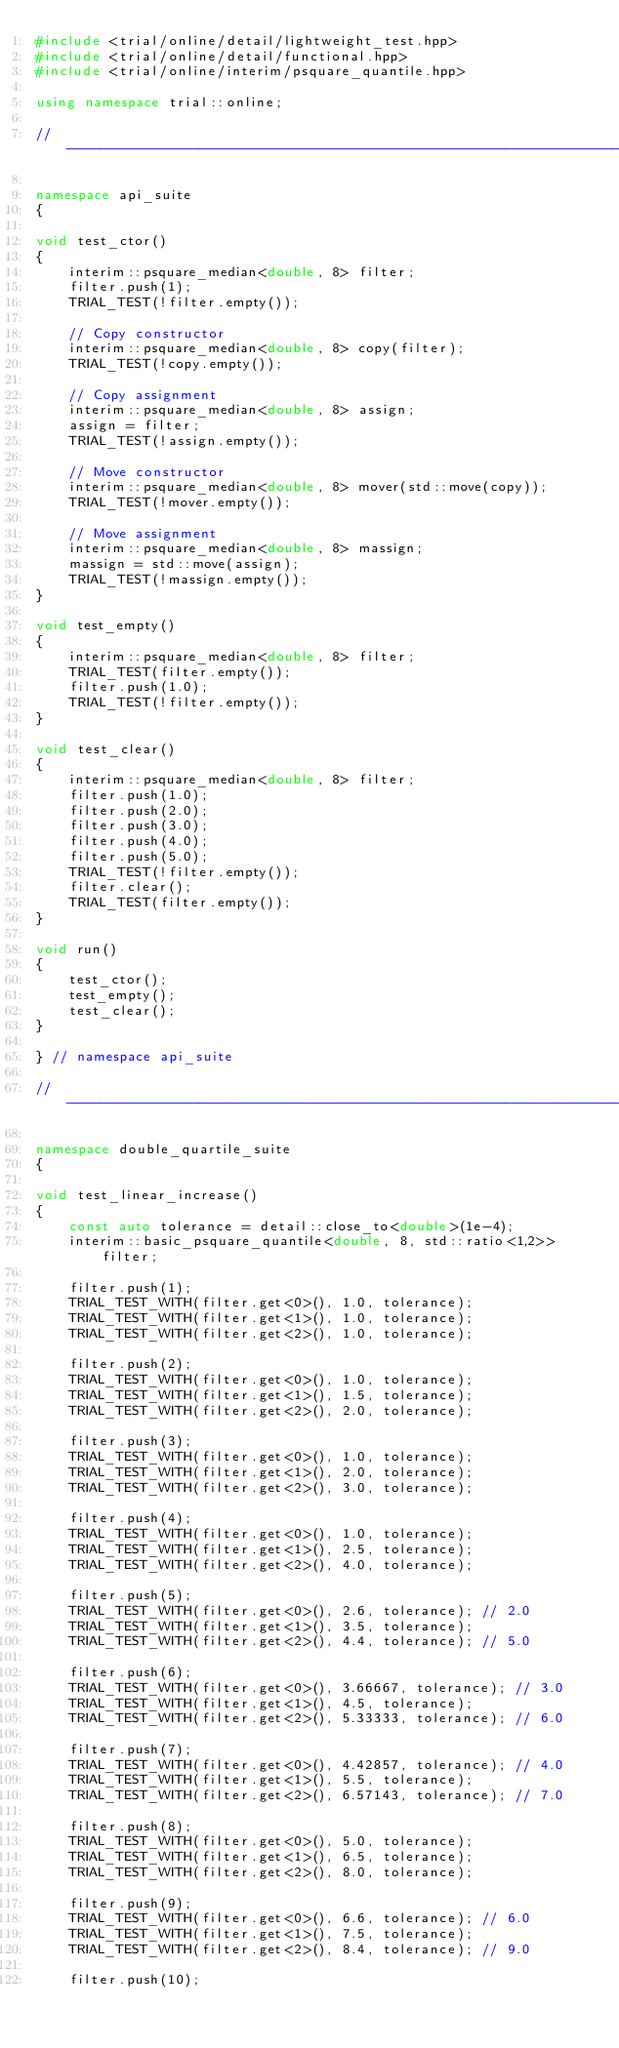Convert code to text. <code><loc_0><loc_0><loc_500><loc_500><_C++_>#include <trial/online/detail/lightweight_test.hpp>
#include <trial/online/detail/functional.hpp>
#include <trial/online/interim/psquare_quantile.hpp>

using namespace trial::online;

//-----------------------------------------------------------------------------

namespace api_suite
{

void test_ctor()
{
    interim::psquare_median<double, 8> filter;
    filter.push(1);
    TRIAL_TEST(!filter.empty());

    // Copy constructor
    interim::psquare_median<double, 8> copy(filter);
    TRIAL_TEST(!copy.empty());

    // Copy assignment
    interim::psquare_median<double, 8> assign;
    assign = filter;
    TRIAL_TEST(!assign.empty());

    // Move constructor
    interim::psquare_median<double, 8> mover(std::move(copy));
    TRIAL_TEST(!mover.empty());

    // Move assignment
    interim::psquare_median<double, 8> massign;
    massign = std::move(assign);
    TRIAL_TEST(!massign.empty());
}

void test_empty()
{
    interim::psquare_median<double, 8> filter;
    TRIAL_TEST(filter.empty());
    filter.push(1.0);
    TRIAL_TEST(!filter.empty());
}

void test_clear()
{
    interim::psquare_median<double, 8> filter;
    filter.push(1.0);
    filter.push(2.0);
    filter.push(3.0);
    filter.push(4.0);
    filter.push(5.0);
    TRIAL_TEST(!filter.empty());
    filter.clear();
    TRIAL_TEST(filter.empty());
}

void run()
{
    test_ctor();
    test_empty();
    test_clear();
}

} // namespace api_suite

//-----------------------------------------------------------------------------

namespace double_quartile_suite
{

void test_linear_increase()
{
    const auto tolerance = detail::close_to<double>(1e-4);
    interim::basic_psquare_quantile<double, 8, std::ratio<1,2>> filter;

    filter.push(1);
    TRIAL_TEST_WITH(filter.get<0>(), 1.0, tolerance);
    TRIAL_TEST_WITH(filter.get<1>(), 1.0, tolerance);
    TRIAL_TEST_WITH(filter.get<2>(), 1.0, tolerance);

    filter.push(2);
    TRIAL_TEST_WITH(filter.get<0>(), 1.0, tolerance);
    TRIAL_TEST_WITH(filter.get<1>(), 1.5, tolerance);
    TRIAL_TEST_WITH(filter.get<2>(), 2.0, tolerance);

    filter.push(3);
    TRIAL_TEST_WITH(filter.get<0>(), 1.0, tolerance);
    TRIAL_TEST_WITH(filter.get<1>(), 2.0, tolerance);
    TRIAL_TEST_WITH(filter.get<2>(), 3.0, tolerance);

    filter.push(4);
    TRIAL_TEST_WITH(filter.get<0>(), 1.0, tolerance);
    TRIAL_TEST_WITH(filter.get<1>(), 2.5, tolerance);
    TRIAL_TEST_WITH(filter.get<2>(), 4.0, tolerance);

    filter.push(5);
    TRIAL_TEST_WITH(filter.get<0>(), 2.6, tolerance); // 2.0
    TRIAL_TEST_WITH(filter.get<1>(), 3.5, tolerance);
    TRIAL_TEST_WITH(filter.get<2>(), 4.4, tolerance); // 5.0

    filter.push(6);
    TRIAL_TEST_WITH(filter.get<0>(), 3.66667, tolerance); // 3.0
    TRIAL_TEST_WITH(filter.get<1>(), 4.5, tolerance);
    TRIAL_TEST_WITH(filter.get<2>(), 5.33333, tolerance); // 6.0

    filter.push(7);
    TRIAL_TEST_WITH(filter.get<0>(), 4.42857, tolerance); // 4.0
    TRIAL_TEST_WITH(filter.get<1>(), 5.5, tolerance);
    TRIAL_TEST_WITH(filter.get<2>(), 6.57143, tolerance); // 7.0

    filter.push(8);
    TRIAL_TEST_WITH(filter.get<0>(), 5.0, tolerance);
    TRIAL_TEST_WITH(filter.get<1>(), 6.5, tolerance);
    TRIAL_TEST_WITH(filter.get<2>(), 8.0, tolerance);

    filter.push(9);
    TRIAL_TEST_WITH(filter.get<0>(), 6.6, tolerance); // 6.0
    TRIAL_TEST_WITH(filter.get<1>(), 7.5, tolerance);
    TRIAL_TEST_WITH(filter.get<2>(), 8.4, tolerance); // 9.0

    filter.push(10);</code> 